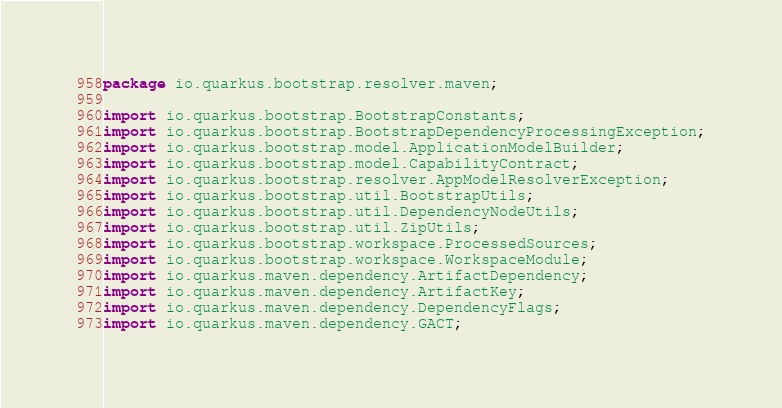<code> <loc_0><loc_0><loc_500><loc_500><_Java_>package io.quarkus.bootstrap.resolver.maven;

import io.quarkus.bootstrap.BootstrapConstants;
import io.quarkus.bootstrap.BootstrapDependencyProcessingException;
import io.quarkus.bootstrap.model.ApplicationModelBuilder;
import io.quarkus.bootstrap.model.CapabilityContract;
import io.quarkus.bootstrap.resolver.AppModelResolverException;
import io.quarkus.bootstrap.util.BootstrapUtils;
import io.quarkus.bootstrap.util.DependencyNodeUtils;
import io.quarkus.bootstrap.util.ZipUtils;
import io.quarkus.bootstrap.workspace.ProcessedSources;
import io.quarkus.bootstrap.workspace.WorkspaceModule;
import io.quarkus.maven.dependency.ArtifactDependency;
import io.quarkus.maven.dependency.ArtifactKey;
import io.quarkus.maven.dependency.DependencyFlags;
import io.quarkus.maven.dependency.GACT;</code> 